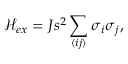<formula> <loc_0><loc_0><loc_500><loc_500>\mathcal { H } _ { e x } = J s ^ { 2 } \sum _ { \langle i j \rangle } \sigma _ { i } \sigma _ { j } ,</formula> 